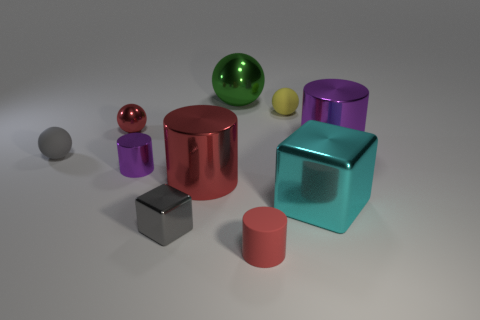There is a purple metallic object to the left of the big shiny cylinder to the left of the large purple thing; what number of tiny metallic things are left of it?
Your response must be concise. 1. Is the color of the big ball the same as the matte cylinder?
Your answer should be very brief. No. Is there a tiny matte ball that has the same color as the rubber cylinder?
Offer a terse response. No. What color is the ball that is the same size as the cyan metal cube?
Your answer should be very brief. Green. Is there a big yellow rubber thing of the same shape as the green shiny thing?
Your response must be concise. No. The big object that is the same color as the rubber cylinder is what shape?
Provide a short and direct response. Cylinder. There is a tiny gray thing in front of the gray rubber ball on the left side of the big metal ball; is there a small purple shiny cylinder left of it?
Offer a terse response. Yes. The red metal thing that is the same size as the yellow ball is what shape?
Your answer should be compact. Sphere. What is the color of the other matte object that is the same shape as the small yellow thing?
Give a very brief answer. Gray. What number of objects are green shiny balls or red objects?
Make the answer very short. 4. 